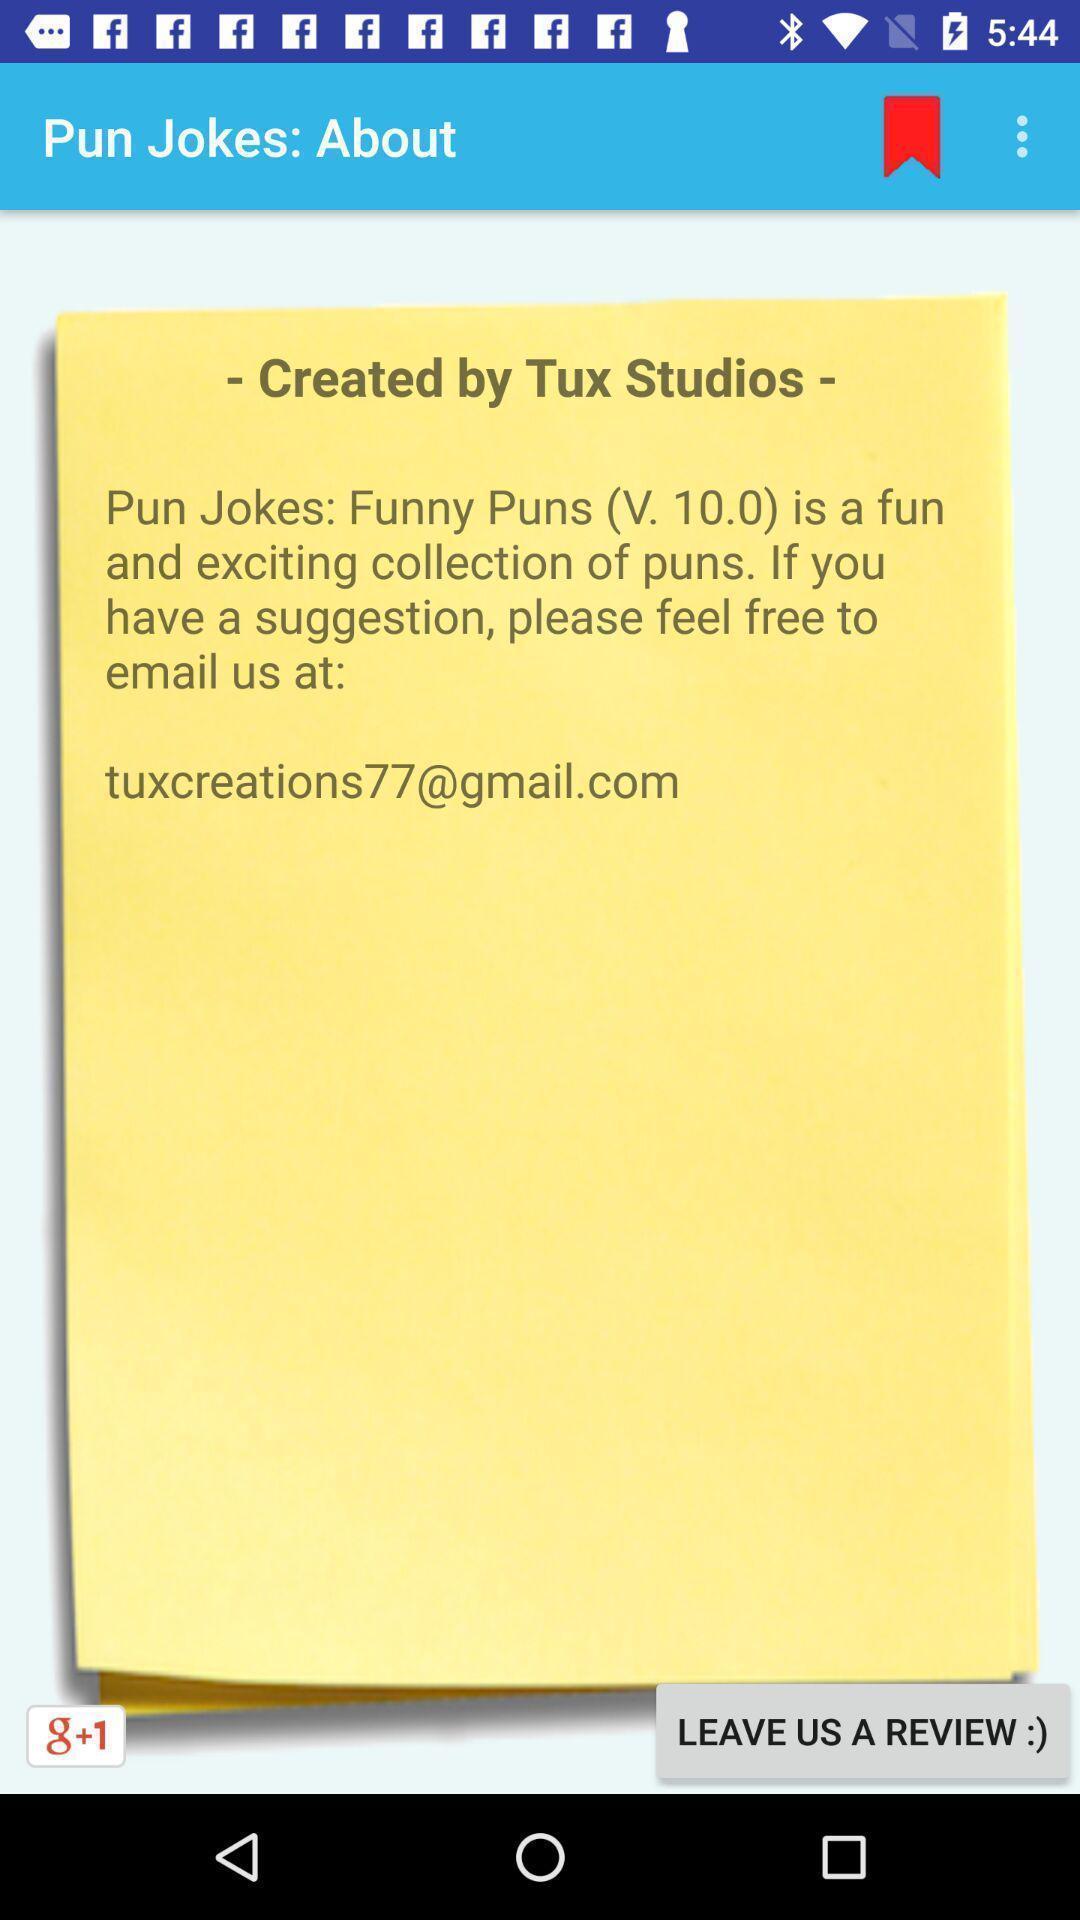Tell me about the visual elements in this screen capture. Pop up of created by tux studios. 